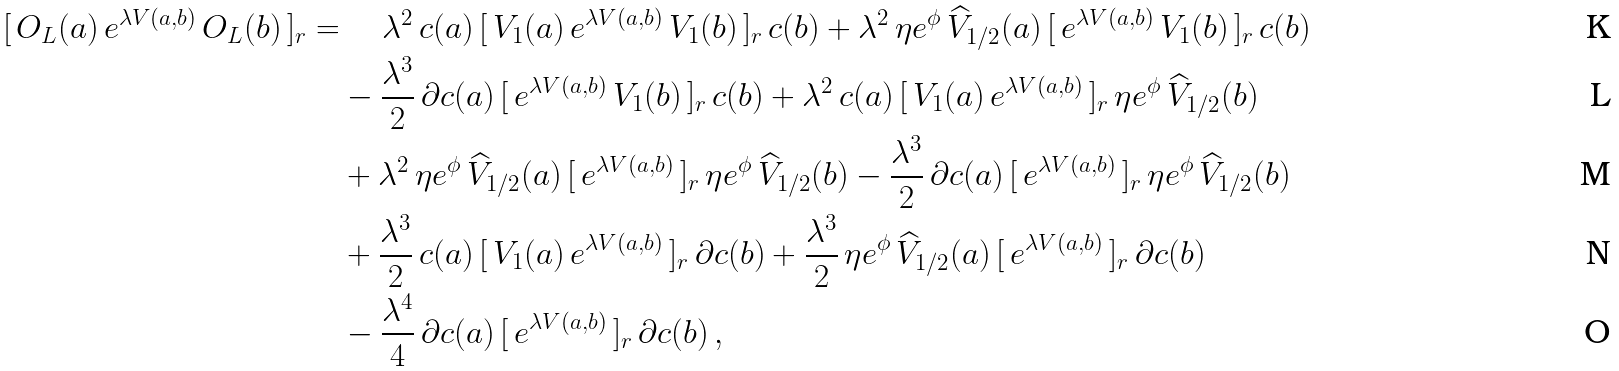Convert formula to latex. <formula><loc_0><loc_0><loc_500><loc_500>[ \, O _ { L } ( a ) \, e ^ { \lambda V ( a , b ) } \, O _ { L } ( b ) \, ] _ { r } & = \quad \lambda ^ { 2 } \, c ( a ) \, [ \, V _ { 1 } ( a ) \, e ^ { \lambda V ( a , b ) } \, V _ { 1 } ( b ) \, ] _ { r } \, c ( b ) + \lambda ^ { 2 } \, \eta e ^ { \phi } \, \widehat { V } _ { 1 / 2 } ( a ) \, [ \, e ^ { \lambda V ( a , b ) } \, V _ { 1 } ( b ) \, ] _ { r } \, c ( b ) \\ & \quad - \frac { \lambda ^ { 3 } } { 2 } \, \partial c ( a ) \, [ \, e ^ { \lambda V ( a , b ) } \, V _ { 1 } ( b ) \, ] _ { r } \, c ( b ) + \lambda ^ { 2 } \, c ( a ) \, [ \, V _ { 1 } ( a ) \, e ^ { \lambda V ( a , b ) } \, ] _ { r } \, \eta e ^ { \phi } \, \widehat { V } _ { 1 / 2 } ( b ) \\ & \quad + \lambda ^ { 2 } \, \eta e ^ { \phi } \, \widehat { V } _ { 1 / 2 } ( a ) \, [ \, e ^ { \lambda V ( a , b ) } \, ] _ { r } \, \eta e ^ { \phi } \, \widehat { V } _ { 1 / 2 } ( b ) - \frac { \lambda ^ { 3 } } { 2 } \, \partial c ( a ) \, [ \, e ^ { \lambda V ( a , b ) } \, ] _ { r } \, \eta e ^ { \phi } \, \widehat { V } _ { 1 / 2 } ( b ) \\ & \quad + \frac { \lambda ^ { 3 } } { 2 } \, c ( a ) \, [ \, V _ { 1 } ( a ) \, e ^ { \lambda V ( a , b ) } \, ] _ { r } \, \partial c ( b ) + \frac { \lambda ^ { 3 } } { 2 } \, \eta e ^ { \phi } \, \widehat { V } _ { 1 / 2 } ( a ) \, [ \, e ^ { \lambda V ( a , b ) } \, ] _ { r } \, \partial c ( b ) \\ & \quad - \frac { \lambda ^ { 4 } } { 4 } \, \partial c ( a ) \, [ \, e ^ { \lambda V ( a , b ) } \, ] _ { r } \, \partial c ( b ) \, ,</formula> 